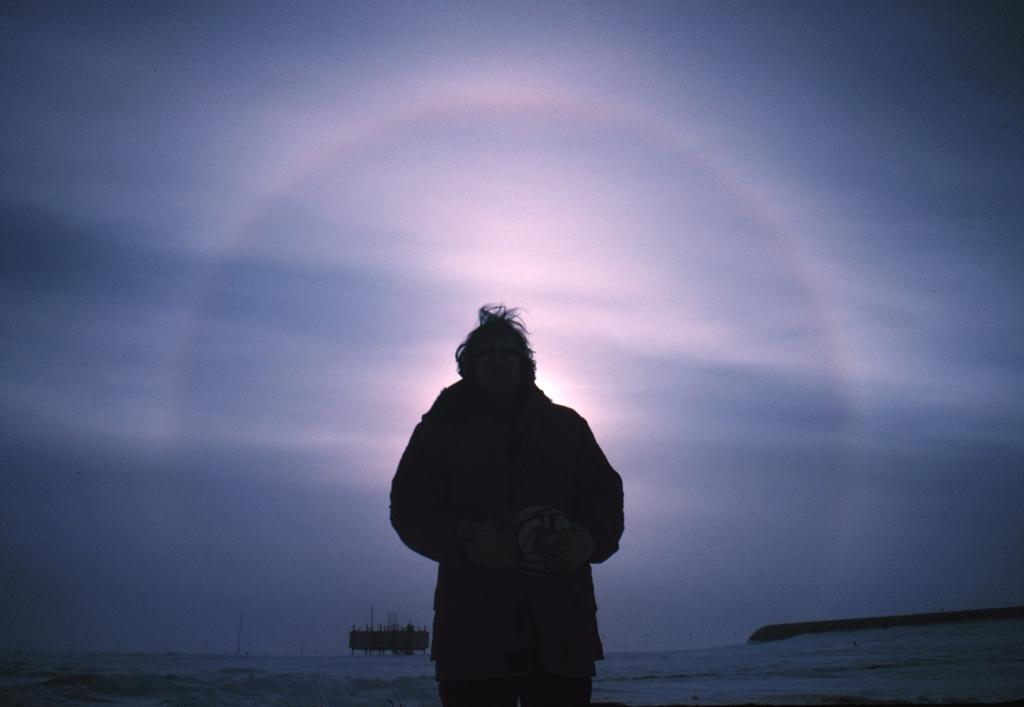What is the main subject of the image? There is a person in the image. What is the person doing in the image? The person is standing. What can be seen in the background of the image? The sky is visible in the background of the image. What type of basin is being used by the maid in the image? There is no basin or maid present in the image. How does the person in the image provide support to others? The person in the image is standing, but there is no indication of them providing support to others. 